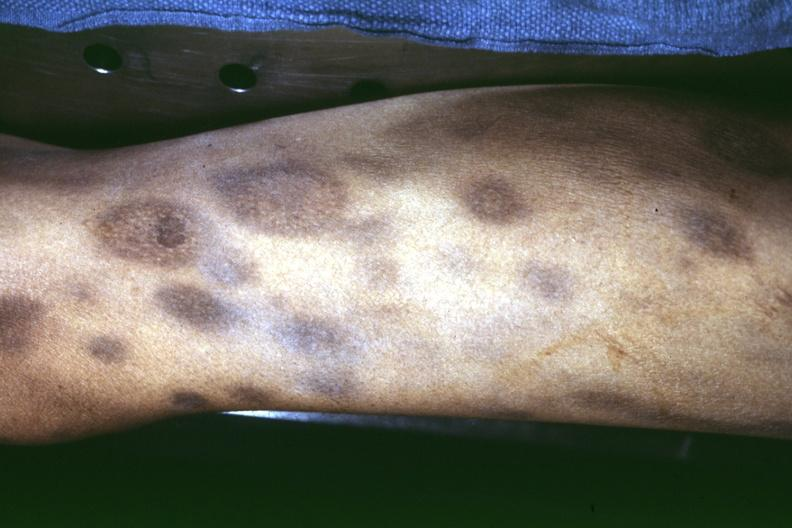where is this?
Answer the question using a single word or phrase. Skin 